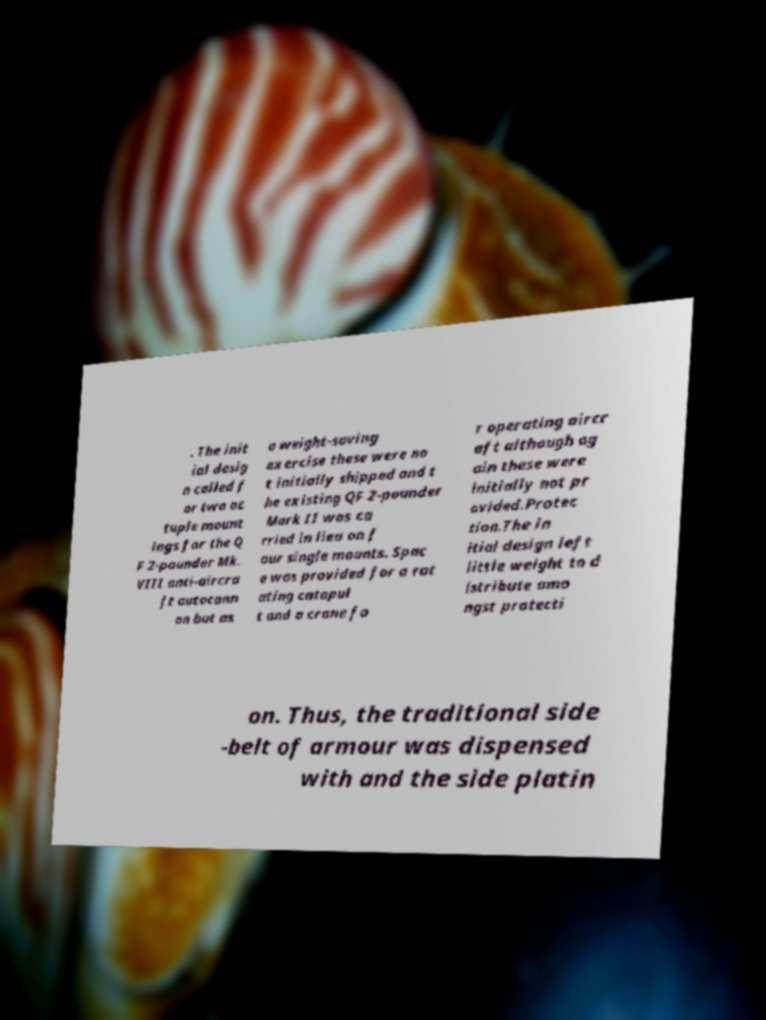Please read and relay the text visible in this image. What does it say? . The init ial desig n called f or two oc tuple mount ings for the Q F 2-pounder Mk. VIII anti-aircra ft autocann on but as a weight-saving exercise these were no t initially shipped and t he existing QF 2-pounder Mark II was ca rried in lieu on f our single mounts. Spac e was provided for a rot ating catapul t and a crane fo r operating aircr aft although ag ain these were initially not pr ovided.Protec tion.The in itial design left little weight to d istribute amo ngst protecti on. Thus, the traditional side -belt of armour was dispensed with and the side platin 